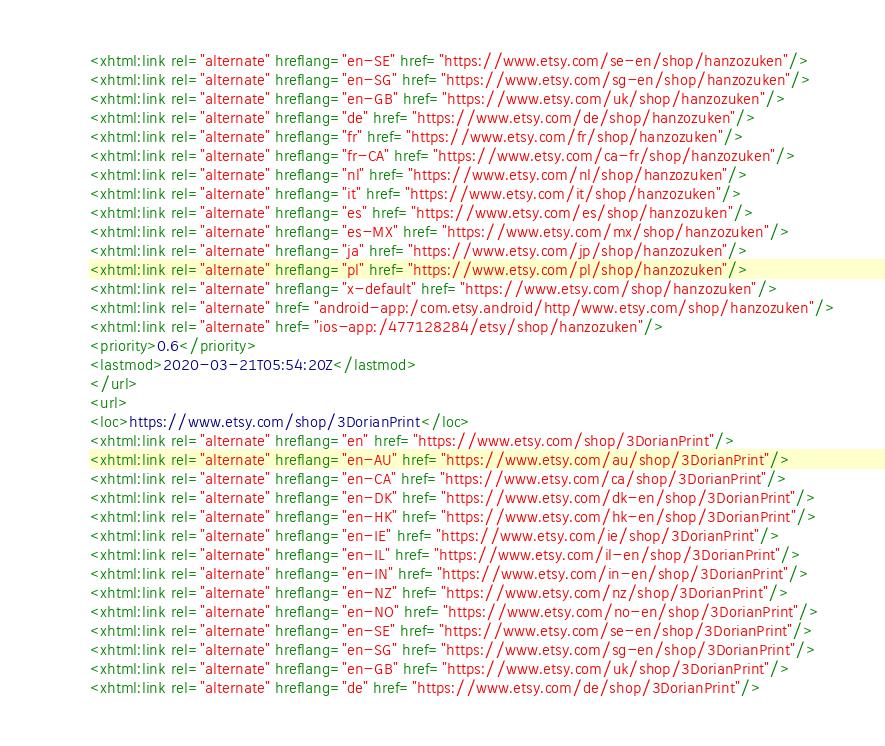<code> <loc_0><loc_0><loc_500><loc_500><_XML_><xhtml:link rel="alternate" hreflang="en-SE" href="https://www.etsy.com/se-en/shop/hanzozuken"/>
<xhtml:link rel="alternate" hreflang="en-SG" href="https://www.etsy.com/sg-en/shop/hanzozuken"/>
<xhtml:link rel="alternate" hreflang="en-GB" href="https://www.etsy.com/uk/shop/hanzozuken"/>
<xhtml:link rel="alternate" hreflang="de" href="https://www.etsy.com/de/shop/hanzozuken"/>
<xhtml:link rel="alternate" hreflang="fr" href="https://www.etsy.com/fr/shop/hanzozuken"/>
<xhtml:link rel="alternate" hreflang="fr-CA" href="https://www.etsy.com/ca-fr/shop/hanzozuken"/>
<xhtml:link rel="alternate" hreflang="nl" href="https://www.etsy.com/nl/shop/hanzozuken"/>
<xhtml:link rel="alternate" hreflang="it" href="https://www.etsy.com/it/shop/hanzozuken"/>
<xhtml:link rel="alternate" hreflang="es" href="https://www.etsy.com/es/shop/hanzozuken"/>
<xhtml:link rel="alternate" hreflang="es-MX" href="https://www.etsy.com/mx/shop/hanzozuken"/>
<xhtml:link rel="alternate" hreflang="ja" href="https://www.etsy.com/jp/shop/hanzozuken"/>
<xhtml:link rel="alternate" hreflang="pl" href="https://www.etsy.com/pl/shop/hanzozuken"/>
<xhtml:link rel="alternate" hreflang="x-default" href="https://www.etsy.com/shop/hanzozuken"/>
<xhtml:link rel="alternate" href="android-app:/com.etsy.android/http/www.etsy.com/shop/hanzozuken"/>
<xhtml:link rel="alternate" href="ios-app:/477128284/etsy/shop/hanzozuken"/>
<priority>0.6</priority>
<lastmod>2020-03-21T05:54:20Z</lastmod>
</url>
<url>
<loc>https://www.etsy.com/shop/3DorianPrint</loc>
<xhtml:link rel="alternate" hreflang="en" href="https://www.etsy.com/shop/3DorianPrint"/>
<xhtml:link rel="alternate" hreflang="en-AU" href="https://www.etsy.com/au/shop/3DorianPrint"/>
<xhtml:link rel="alternate" hreflang="en-CA" href="https://www.etsy.com/ca/shop/3DorianPrint"/>
<xhtml:link rel="alternate" hreflang="en-DK" href="https://www.etsy.com/dk-en/shop/3DorianPrint"/>
<xhtml:link rel="alternate" hreflang="en-HK" href="https://www.etsy.com/hk-en/shop/3DorianPrint"/>
<xhtml:link rel="alternate" hreflang="en-IE" href="https://www.etsy.com/ie/shop/3DorianPrint"/>
<xhtml:link rel="alternate" hreflang="en-IL" href="https://www.etsy.com/il-en/shop/3DorianPrint"/>
<xhtml:link rel="alternate" hreflang="en-IN" href="https://www.etsy.com/in-en/shop/3DorianPrint"/>
<xhtml:link rel="alternate" hreflang="en-NZ" href="https://www.etsy.com/nz/shop/3DorianPrint"/>
<xhtml:link rel="alternate" hreflang="en-NO" href="https://www.etsy.com/no-en/shop/3DorianPrint"/>
<xhtml:link rel="alternate" hreflang="en-SE" href="https://www.etsy.com/se-en/shop/3DorianPrint"/>
<xhtml:link rel="alternate" hreflang="en-SG" href="https://www.etsy.com/sg-en/shop/3DorianPrint"/>
<xhtml:link rel="alternate" hreflang="en-GB" href="https://www.etsy.com/uk/shop/3DorianPrint"/>
<xhtml:link rel="alternate" hreflang="de" href="https://www.etsy.com/de/shop/3DorianPrint"/></code> 